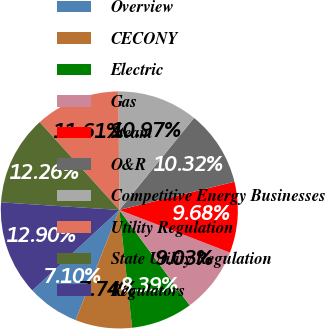Convert chart to OTSL. <chart><loc_0><loc_0><loc_500><loc_500><pie_chart><fcel>Overview<fcel>CECONY<fcel>Electric<fcel>Gas<fcel>Steam<fcel>O&R<fcel>Competitive Energy Businesses<fcel>Utility Regulation<fcel>State Utility Regulation<fcel>Regulators<nl><fcel>7.1%<fcel>7.74%<fcel>8.39%<fcel>9.03%<fcel>9.68%<fcel>10.32%<fcel>10.97%<fcel>11.61%<fcel>12.26%<fcel>12.9%<nl></chart> 